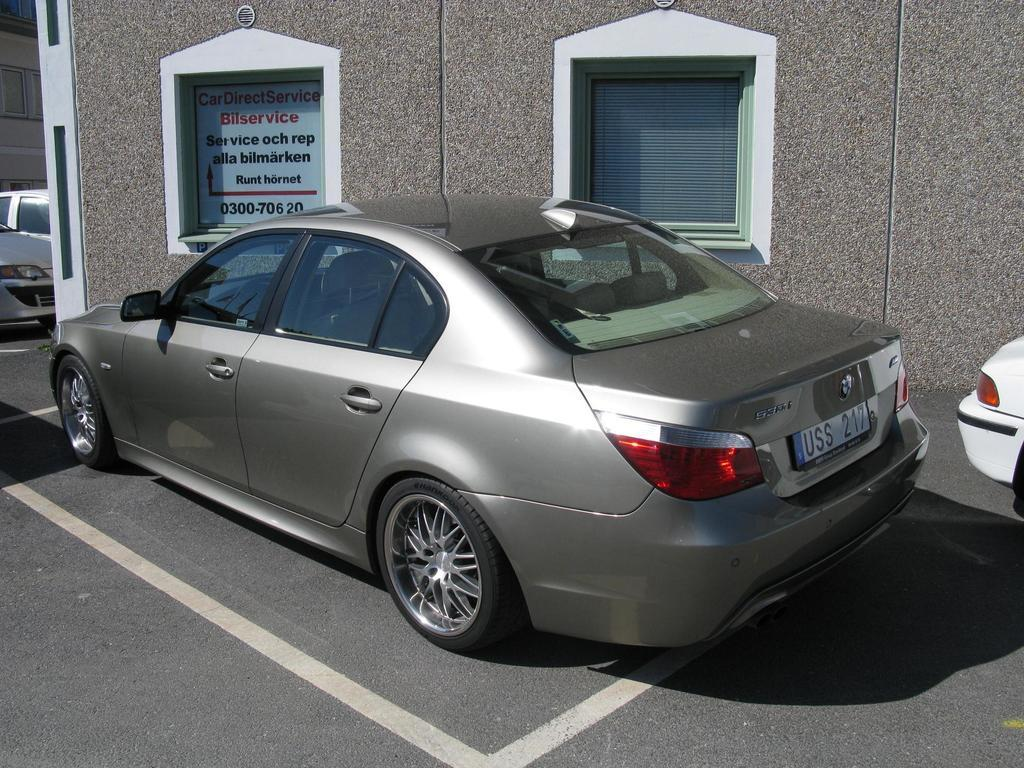What type of vehicles can be seen on the road in the image? There are cars on the road in the image. What structures are visible in the image? There are buildings in the image. Can you describe any text visible in the image? There is text written on an object on the wall in the image. What type of openings can be seen in the buildings? There are windows in the image. What type of window covering is present in the image? There is a window blind in the image. What type of cherry tree can be seen in the yard at night in the image? There is no cherry tree or yard visible in the image, and the time of day is not specified. 